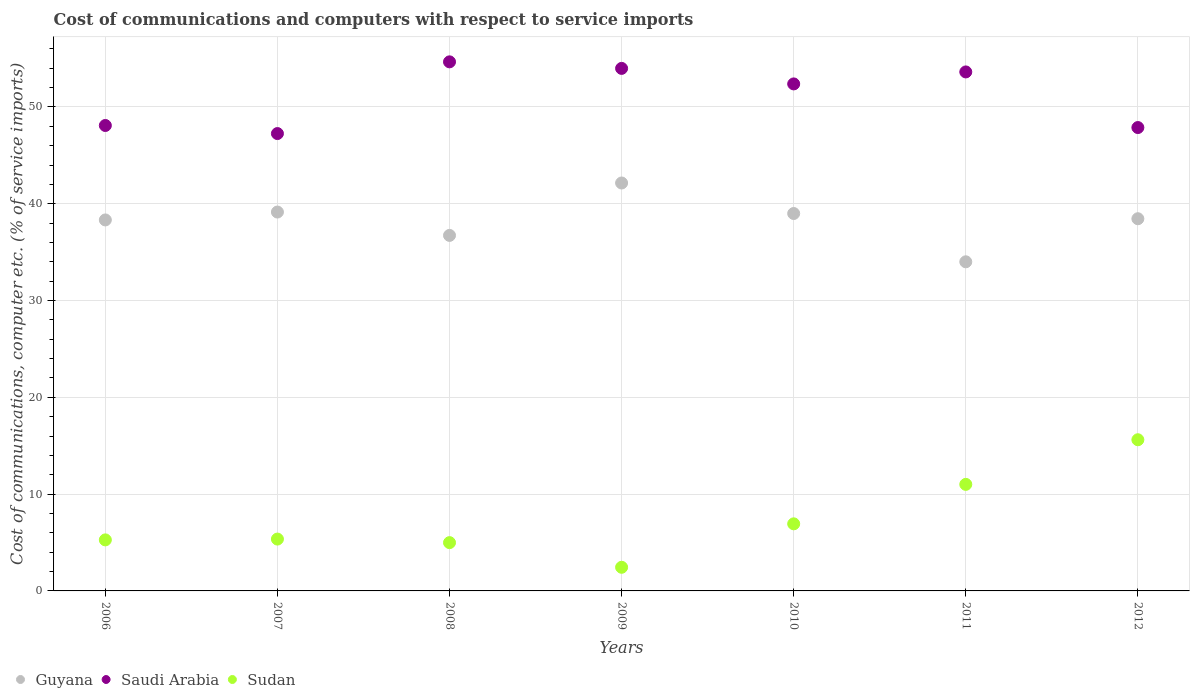Is the number of dotlines equal to the number of legend labels?
Your answer should be very brief. Yes. What is the cost of communications and computers in Guyana in 2006?
Keep it short and to the point. 38.33. Across all years, what is the maximum cost of communications and computers in Saudi Arabia?
Ensure brevity in your answer.  54.66. Across all years, what is the minimum cost of communications and computers in Saudi Arabia?
Offer a terse response. 47.25. In which year was the cost of communications and computers in Guyana minimum?
Ensure brevity in your answer.  2011. What is the total cost of communications and computers in Sudan in the graph?
Your response must be concise. 51.61. What is the difference between the cost of communications and computers in Saudi Arabia in 2008 and that in 2011?
Keep it short and to the point. 1.04. What is the difference between the cost of communications and computers in Guyana in 2009 and the cost of communications and computers in Saudi Arabia in 2008?
Your answer should be very brief. -12.52. What is the average cost of communications and computers in Guyana per year?
Offer a very short reply. 38.25. In the year 2006, what is the difference between the cost of communications and computers in Guyana and cost of communications and computers in Saudi Arabia?
Keep it short and to the point. -9.76. What is the ratio of the cost of communications and computers in Saudi Arabia in 2006 to that in 2011?
Give a very brief answer. 0.9. Is the cost of communications and computers in Guyana in 2011 less than that in 2012?
Keep it short and to the point. Yes. What is the difference between the highest and the second highest cost of communications and computers in Sudan?
Provide a short and direct response. 4.61. What is the difference between the highest and the lowest cost of communications and computers in Saudi Arabia?
Provide a short and direct response. 7.41. Is the sum of the cost of communications and computers in Sudan in 2006 and 2009 greater than the maximum cost of communications and computers in Saudi Arabia across all years?
Your answer should be compact. No. Does the cost of communications and computers in Guyana monotonically increase over the years?
Ensure brevity in your answer.  No. Is the cost of communications and computers in Sudan strictly greater than the cost of communications and computers in Saudi Arabia over the years?
Keep it short and to the point. No. How many dotlines are there?
Offer a very short reply. 3. How many years are there in the graph?
Your response must be concise. 7. What is the difference between two consecutive major ticks on the Y-axis?
Keep it short and to the point. 10. Are the values on the major ticks of Y-axis written in scientific E-notation?
Ensure brevity in your answer.  No. Does the graph contain grids?
Make the answer very short. Yes. Where does the legend appear in the graph?
Give a very brief answer. Bottom left. What is the title of the graph?
Your answer should be compact. Cost of communications and computers with respect to service imports. Does "Sao Tome and Principe" appear as one of the legend labels in the graph?
Your answer should be very brief. No. What is the label or title of the Y-axis?
Offer a very short reply. Cost of communications, computer etc. (% of service imports). What is the Cost of communications, computer etc. (% of service imports) in Guyana in 2006?
Offer a terse response. 38.33. What is the Cost of communications, computer etc. (% of service imports) of Saudi Arabia in 2006?
Ensure brevity in your answer.  48.08. What is the Cost of communications, computer etc. (% of service imports) of Sudan in 2006?
Your response must be concise. 5.27. What is the Cost of communications, computer etc. (% of service imports) of Guyana in 2007?
Your response must be concise. 39.14. What is the Cost of communications, computer etc. (% of service imports) of Saudi Arabia in 2007?
Your answer should be very brief. 47.25. What is the Cost of communications, computer etc. (% of service imports) of Sudan in 2007?
Make the answer very short. 5.36. What is the Cost of communications, computer etc. (% of service imports) of Guyana in 2008?
Your answer should be very brief. 36.73. What is the Cost of communications, computer etc. (% of service imports) in Saudi Arabia in 2008?
Ensure brevity in your answer.  54.66. What is the Cost of communications, computer etc. (% of service imports) of Sudan in 2008?
Provide a short and direct response. 4.99. What is the Cost of communications, computer etc. (% of service imports) of Guyana in 2009?
Ensure brevity in your answer.  42.14. What is the Cost of communications, computer etc. (% of service imports) of Saudi Arabia in 2009?
Your answer should be very brief. 53.98. What is the Cost of communications, computer etc. (% of service imports) of Sudan in 2009?
Offer a terse response. 2.44. What is the Cost of communications, computer etc. (% of service imports) in Guyana in 2010?
Your answer should be compact. 38.99. What is the Cost of communications, computer etc. (% of service imports) of Saudi Arabia in 2010?
Your answer should be compact. 52.38. What is the Cost of communications, computer etc. (% of service imports) of Sudan in 2010?
Keep it short and to the point. 6.93. What is the Cost of communications, computer etc. (% of service imports) in Guyana in 2011?
Provide a short and direct response. 34. What is the Cost of communications, computer etc. (% of service imports) in Saudi Arabia in 2011?
Your response must be concise. 53.62. What is the Cost of communications, computer etc. (% of service imports) in Sudan in 2011?
Keep it short and to the point. 11.01. What is the Cost of communications, computer etc. (% of service imports) of Guyana in 2012?
Your answer should be very brief. 38.45. What is the Cost of communications, computer etc. (% of service imports) in Saudi Arabia in 2012?
Give a very brief answer. 47.87. What is the Cost of communications, computer etc. (% of service imports) of Sudan in 2012?
Give a very brief answer. 15.62. Across all years, what is the maximum Cost of communications, computer etc. (% of service imports) of Guyana?
Make the answer very short. 42.14. Across all years, what is the maximum Cost of communications, computer etc. (% of service imports) in Saudi Arabia?
Offer a terse response. 54.66. Across all years, what is the maximum Cost of communications, computer etc. (% of service imports) of Sudan?
Keep it short and to the point. 15.62. Across all years, what is the minimum Cost of communications, computer etc. (% of service imports) in Guyana?
Offer a very short reply. 34. Across all years, what is the minimum Cost of communications, computer etc. (% of service imports) of Saudi Arabia?
Keep it short and to the point. 47.25. Across all years, what is the minimum Cost of communications, computer etc. (% of service imports) of Sudan?
Your response must be concise. 2.44. What is the total Cost of communications, computer etc. (% of service imports) in Guyana in the graph?
Ensure brevity in your answer.  267.77. What is the total Cost of communications, computer etc. (% of service imports) of Saudi Arabia in the graph?
Make the answer very short. 357.83. What is the total Cost of communications, computer etc. (% of service imports) of Sudan in the graph?
Make the answer very short. 51.61. What is the difference between the Cost of communications, computer etc. (% of service imports) of Guyana in 2006 and that in 2007?
Provide a short and direct response. -0.82. What is the difference between the Cost of communications, computer etc. (% of service imports) of Saudi Arabia in 2006 and that in 2007?
Keep it short and to the point. 0.83. What is the difference between the Cost of communications, computer etc. (% of service imports) of Sudan in 2006 and that in 2007?
Provide a succinct answer. -0.08. What is the difference between the Cost of communications, computer etc. (% of service imports) of Guyana in 2006 and that in 2008?
Ensure brevity in your answer.  1.6. What is the difference between the Cost of communications, computer etc. (% of service imports) of Saudi Arabia in 2006 and that in 2008?
Your answer should be compact. -6.57. What is the difference between the Cost of communications, computer etc. (% of service imports) of Sudan in 2006 and that in 2008?
Provide a succinct answer. 0.28. What is the difference between the Cost of communications, computer etc. (% of service imports) of Guyana in 2006 and that in 2009?
Keep it short and to the point. -3.82. What is the difference between the Cost of communications, computer etc. (% of service imports) in Saudi Arabia in 2006 and that in 2009?
Keep it short and to the point. -5.9. What is the difference between the Cost of communications, computer etc. (% of service imports) in Sudan in 2006 and that in 2009?
Keep it short and to the point. 2.83. What is the difference between the Cost of communications, computer etc. (% of service imports) of Guyana in 2006 and that in 2010?
Offer a very short reply. -0.66. What is the difference between the Cost of communications, computer etc. (% of service imports) in Saudi Arabia in 2006 and that in 2010?
Offer a terse response. -4.3. What is the difference between the Cost of communications, computer etc. (% of service imports) in Sudan in 2006 and that in 2010?
Make the answer very short. -1.66. What is the difference between the Cost of communications, computer etc. (% of service imports) of Guyana in 2006 and that in 2011?
Offer a terse response. 4.33. What is the difference between the Cost of communications, computer etc. (% of service imports) in Saudi Arabia in 2006 and that in 2011?
Provide a succinct answer. -5.53. What is the difference between the Cost of communications, computer etc. (% of service imports) of Sudan in 2006 and that in 2011?
Your answer should be very brief. -5.73. What is the difference between the Cost of communications, computer etc. (% of service imports) in Guyana in 2006 and that in 2012?
Ensure brevity in your answer.  -0.13. What is the difference between the Cost of communications, computer etc. (% of service imports) of Saudi Arabia in 2006 and that in 2012?
Provide a short and direct response. 0.21. What is the difference between the Cost of communications, computer etc. (% of service imports) of Sudan in 2006 and that in 2012?
Your answer should be very brief. -10.35. What is the difference between the Cost of communications, computer etc. (% of service imports) in Guyana in 2007 and that in 2008?
Offer a terse response. 2.41. What is the difference between the Cost of communications, computer etc. (% of service imports) in Saudi Arabia in 2007 and that in 2008?
Provide a succinct answer. -7.41. What is the difference between the Cost of communications, computer etc. (% of service imports) in Sudan in 2007 and that in 2008?
Offer a very short reply. 0.37. What is the difference between the Cost of communications, computer etc. (% of service imports) in Guyana in 2007 and that in 2009?
Your answer should be very brief. -3. What is the difference between the Cost of communications, computer etc. (% of service imports) in Saudi Arabia in 2007 and that in 2009?
Your answer should be compact. -6.73. What is the difference between the Cost of communications, computer etc. (% of service imports) of Sudan in 2007 and that in 2009?
Ensure brevity in your answer.  2.91. What is the difference between the Cost of communications, computer etc. (% of service imports) in Guyana in 2007 and that in 2010?
Offer a terse response. 0.15. What is the difference between the Cost of communications, computer etc. (% of service imports) in Saudi Arabia in 2007 and that in 2010?
Offer a terse response. -5.13. What is the difference between the Cost of communications, computer etc. (% of service imports) in Sudan in 2007 and that in 2010?
Provide a succinct answer. -1.57. What is the difference between the Cost of communications, computer etc. (% of service imports) in Guyana in 2007 and that in 2011?
Ensure brevity in your answer.  5.14. What is the difference between the Cost of communications, computer etc. (% of service imports) of Saudi Arabia in 2007 and that in 2011?
Your answer should be very brief. -6.37. What is the difference between the Cost of communications, computer etc. (% of service imports) of Sudan in 2007 and that in 2011?
Make the answer very short. -5.65. What is the difference between the Cost of communications, computer etc. (% of service imports) in Guyana in 2007 and that in 2012?
Your answer should be very brief. 0.69. What is the difference between the Cost of communications, computer etc. (% of service imports) of Saudi Arabia in 2007 and that in 2012?
Your answer should be very brief. -0.62. What is the difference between the Cost of communications, computer etc. (% of service imports) of Sudan in 2007 and that in 2012?
Provide a short and direct response. -10.26. What is the difference between the Cost of communications, computer etc. (% of service imports) in Guyana in 2008 and that in 2009?
Give a very brief answer. -5.42. What is the difference between the Cost of communications, computer etc. (% of service imports) of Saudi Arabia in 2008 and that in 2009?
Provide a succinct answer. 0.68. What is the difference between the Cost of communications, computer etc. (% of service imports) in Sudan in 2008 and that in 2009?
Your answer should be compact. 2.55. What is the difference between the Cost of communications, computer etc. (% of service imports) of Guyana in 2008 and that in 2010?
Your response must be concise. -2.26. What is the difference between the Cost of communications, computer etc. (% of service imports) in Saudi Arabia in 2008 and that in 2010?
Your response must be concise. 2.28. What is the difference between the Cost of communications, computer etc. (% of service imports) in Sudan in 2008 and that in 2010?
Offer a very short reply. -1.94. What is the difference between the Cost of communications, computer etc. (% of service imports) of Guyana in 2008 and that in 2011?
Provide a short and direct response. 2.73. What is the difference between the Cost of communications, computer etc. (% of service imports) in Saudi Arabia in 2008 and that in 2011?
Provide a succinct answer. 1.04. What is the difference between the Cost of communications, computer etc. (% of service imports) of Sudan in 2008 and that in 2011?
Offer a terse response. -6.02. What is the difference between the Cost of communications, computer etc. (% of service imports) of Guyana in 2008 and that in 2012?
Offer a very short reply. -1.72. What is the difference between the Cost of communications, computer etc. (% of service imports) in Saudi Arabia in 2008 and that in 2012?
Keep it short and to the point. 6.79. What is the difference between the Cost of communications, computer etc. (% of service imports) in Sudan in 2008 and that in 2012?
Give a very brief answer. -10.63. What is the difference between the Cost of communications, computer etc. (% of service imports) in Guyana in 2009 and that in 2010?
Make the answer very short. 3.15. What is the difference between the Cost of communications, computer etc. (% of service imports) of Saudi Arabia in 2009 and that in 2010?
Offer a very short reply. 1.6. What is the difference between the Cost of communications, computer etc. (% of service imports) of Sudan in 2009 and that in 2010?
Your answer should be very brief. -4.49. What is the difference between the Cost of communications, computer etc. (% of service imports) in Guyana in 2009 and that in 2011?
Offer a very short reply. 8.14. What is the difference between the Cost of communications, computer etc. (% of service imports) of Saudi Arabia in 2009 and that in 2011?
Offer a terse response. 0.37. What is the difference between the Cost of communications, computer etc. (% of service imports) of Sudan in 2009 and that in 2011?
Offer a terse response. -8.56. What is the difference between the Cost of communications, computer etc. (% of service imports) in Guyana in 2009 and that in 2012?
Give a very brief answer. 3.69. What is the difference between the Cost of communications, computer etc. (% of service imports) in Saudi Arabia in 2009 and that in 2012?
Your answer should be compact. 6.11. What is the difference between the Cost of communications, computer etc. (% of service imports) in Sudan in 2009 and that in 2012?
Your response must be concise. -13.18. What is the difference between the Cost of communications, computer etc. (% of service imports) in Guyana in 2010 and that in 2011?
Give a very brief answer. 4.99. What is the difference between the Cost of communications, computer etc. (% of service imports) in Saudi Arabia in 2010 and that in 2011?
Ensure brevity in your answer.  -1.24. What is the difference between the Cost of communications, computer etc. (% of service imports) of Sudan in 2010 and that in 2011?
Your answer should be compact. -4.08. What is the difference between the Cost of communications, computer etc. (% of service imports) of Guyana in 2010 and that in 2012?
Offer a terse response. 0.54. What is the difference between the Cost of communications, computer etc. (% of service imports) of Saudi Arabia in 2010 and that in 2012?
Your response must be concise. 4.51. What is the difference between the Cost of communications, computer etc. (% of service imports) in Sudan in 2010 and that in 2012?
Your response must be concise. -8.69. What is the difference between the Cost of communications, computer etc. (% of service imports) of Guyana in 2011 and that in 2012?
Provide a succinct answer. -4.45. What is the difference between the Cost of communications, computer etc. (% of service imports) in Saudi Arabia in 2011 and that in 2012?
Ensure brevity in your answer.  5.75. What is the difference between the Cost of communications, computer etc. (% of service imports) of Sudan in 2011 and that in 2012?
Keep it short and to the point. -4.61. What is the difference between the Cost of communications, computer etc. (% of service imports) of Guyana in 2006 and the Cost of communications, computer etc. (% of service imports) of Saudi Arabia in 2007?
Give a very brief answer. -8.92. What is the difference between the Cost of communications, computer etc. (% of service imports) of Guyana in 2006 and the Cost of communications, computer etc. (% of service imports) of Sudan in 2007?
Provide a short and direct response. 32.97. What is the difference between the Cost of communications, computer etc. (% of service imports) of Saudi Arabia in 2006 and the Cost of communications, computer etc. (% of service imports) of Sudan in 2007?
Provide a short and direct response. 42.73. What is the difference between the Cost of communications, computer etc. (% of service imports) of Guyana in 2006 and the Cost of communications, computer etc. (% of service imports) of Saudi Arabia in 2008?
Your response must be concise. -16.33. What is the difference between the Cost of communications, computer etc. (% of service imports) of Guyana in 2006 and the Cost of communications, computer etc. (% of service imports) of Sudan in 2008?
Your answer should be very brief. 33.34. What is the difference between the Cost of communications, computer etc. (% of service imports) in Saudi Arabia in 2006 and the Cost of communications, computer etc. (% of service imports) in Sudan in 2008?
Ensure brevity in your answer.  43.09. What is the difference between the Cost of communications, computer etc. (% of service imports) of Guyana in 2006 and the Cost of communications, computer etc. (% of service imports) of Saudi Arabia in 2009?
Offer a terse response. -15.66. What is the difference between the Cost of communications, computer etc. (% of service imports) in Guyana in 2006 and the Cost of communications, computer etc. (% of service imports) in Sudan in 2009?
Provide a succinct answer. 35.88. What is the difference between the Cost of communications, computer etc. (% of service imports) in Saudi Arabia in 2006 and the Cost of communications, computer etc. (% of service imports) in Sudan in 2009?
Provide a short and direct response. 45.64. What is the difference between the Cost of communications, computer etc. (% of service imports) of Guyana in 2006 and the Cost of communications, computer etc. (% of service imports) of Saudi Arabia in 2010?
Offer a very short reply. -14.05. What is the difference between the Cost of communications, computer etc. (% of service imports) of Guyana in 2006 and the Cost of communications, computer etc. (% of service imports) of Sudan in 2010?
Your answer should be very brief. 31.39. What is the difference between the Cost of communications, computer etc. (% of service imports) of Saudi Arabia in 2006 and the Cost of communications, computer etc. (% of service imports) of Sudan in 2010?
Give a very brief answer. 41.15. What is the difference between the Cost of communications, computer etc. (% of service imports) of Guyana in 2006 and the Cost of communications, computer etc. (% of service imports) of Saudi Arabia in 2011?
Make the answer very short. -15.29. What is the difference between the Cost of communications, computer etc. (% of service imports) of Guyana in 2006 and the Cost of communications, computer etc. (% of service imports) of Sudan in 2011?
Give a very brief answer. 27.32. What is the difference between the Cost of communications, computer etc. (% of service imports) in Saudi Arabia in 2006 and the Cost of communications, computer etc. (% of service imports) in Sudan in 2011?
Provide a succinct answer. 37.08. What is the difference between the Cost of communications, computer etc. (% of service imports) of Guyana in 2006 and the Cost of communications, computer etc. (% of service imports) of Saudi Arabia in 2012?
Offer a very short reply. -9.54. What is the difference between the Cost of communications, computer etc. (% of service imports) of Guyana in 2006 and the Cost of communications, computer etc. (% of service imports) of Sudan in 2012?
Provide a succinct answer. 22.71. What is the difference between the Cost of communications, computer etc. (% of service imports) in Saudi Arabia in 2006 and the Cost of communications, computer etc. (% of service imports) in Sudan in 2012?
Offer a terse response. 32.46. What is the difference between the Cost of communications, computer etc. (% of service imports) in Guyana in 2007 and the Cost of communications, computer etc. (% of service imports) in Saudi Arabia in 2008?
Your response must be concise. -15.52. What is the difference between the Cost of communications, computer etc. (% of service imports) in Guyana in 2007 and the Cost of communications, computer etc. (% of service imports) in Sudan in 2008?
Keep it short and to the point. 34.15. What is the difference between the Cost of communications, computer etc. (% of service imports) in Saudi Arabia in 2007 and the Cost of communications, computer etc. (% of service imports) in Sudan in 2008?
Offer a terse response. 42.26. What is the difference between the Cost of communications, computer etc. (% of service imports) in Guyana in 2007 and the Cost of communications, computer etc. (% of service imports) in Saudi Arabia in 2009?
Provide a short and direct response. -14.84. What is the difference between the Cost of communications, computer etc. (% of service imports) in Guyana in 2007 and the Cost of communications, computer etc. (% of service imports) in Sudan in 2009?
Provide a short and direct response. 36.7. What is the difference between the Cost of communications, computer etc. (% of service imports) in Saudi Arabia in 2007 and the Cost of communications, computer etc. (% of service imports) in Sudan in 2009?
Keep it short and to the point. 44.81. What is the difference between the Cost of communications, computer etc. (% of service imports) of Guyana in 2007 and the Cost of communications, computer etc. (% of service imports) of Saudi Arabia in 2010?
Keep it short and to the point. -13.24. What is the difference between the Cost of communications, computer etc. (% of service imports) of Guyana in 2007 and the Cost of communications, computer etc. (% of service imports) of Sudan in 2010?
Give a very brief answer. 32.21. What is the difference between the Cost of communications, computer etc. (% of service imports) of Saudi Arabia in 2007 and the Cost of communications, computer etc. (% of service imports) of Sudan in 2010?
Give a very brief answer. 40.32. What is the difference between the Cost of communications, computer etc. (% of service imports) of Guyana in 2007 and the Cost of communications, computer etc. (% of service imports) of Saudi Arabia in 2011?
Offer a very short reply. -14.47. What is the difference between the Cost of communications, computer etc. (% of service imports) in Guyana in 2007 and the Cost of communications, computer etc. (% of service imports) in Sudan in 2011?
Keep it short and to the point. 28.13. What is the difference between the Cost of communications, computer etc. (% of service imports) of Saudi Arabia in 2007 and the Cost of communications, computer etc. (% of service imports) of Sudan in 2011?
Offer a terse response. 36.24. What is the difference between the Cost of communications, computer etc. (% of service imports) in Guyana in 2007 and the Cost of communications, computer etc. (% of service imports) in Saudi Arabia in 2012?
Provide a short and direct response. -8.73. What is the difference between the Cost of communications, computer etc. (% of service imports) of Guyana in 2007 and the Cost of communications, computer etc. (% of service imports) of Sudan in 2012?
Offer a terse response. 23.52. What is the difference between the Cost of communications, computer etc. (% of service imports) in Saudi Arabia in 2007 and the Cost of communications, computer etc. (% of service imports) in Sudan in 2012?
Make the answer very short. 31.63. What is the difference between the Cost of communications, computer etc. (% of service imports) of Guyana in 2008 and the Cost of communications, computer etc. (% of service imports) of Saudi Arabia in 2009?
Ensure brevity in your answer.  -17.25. What is the difference between the Cost of communications, computer etc. (% of service imports) in Guyana in 2008 and the Cost of communications, computer etc. (% of service imports) in Sudan in 2009?
Your answer should be compact. 34.28. What is the difference between the Cost of communications, computer etc. (% of service imports) in Saudi Arabia in 2008 and the Cost of communications, computer etc. (% of service imports) in Sudan in 2009?
Ensure brevity in your answer.  52.21. What is the difference between the Cost of communications, computer etc. (% of service imports) of Guyana in 2008 and the Cost of communications, computer etc. (% of service imports) of Saudi Arabia in 2010?
Your answer should be compact. -15.65. What is the difference between the Cost of communications, computer etc. (% of service imports) of Guyana in 2008 and the Cost of communications, computer etc. (% of service imports) of Sudan in 2010?
Offer a terse response. 29.8. What is the difference between the Cost of communications, computer etc. (% of service imports) of Saudi Arabia in 2008 and the Cost of communications, computer etc. (% of service imports) of Sudan in 2010?
Offer a very short reply. 47.73. What is the difference between the Cost of communications, computer etc. (% of service imports) in Guyana in 2008 and the Cost of communications, computer etc. (% of service imports) in Saudi Arabia in 2011?
Your answer should be compact. -16.89. What is the difference between the Cost of communications, computer etc. (% of service imports) in Guyana in 2008 and the Cost of communications, computer etc. (% of service imports) in Sudan in 2011?
Provide a short and direct response. 25.72. What is the difference between the Cost of communications, computer etc. (% of service imports) of Saudi Arabia in 2008 and the Cost of communications, computer etc. (% of service imports) of Sudan in 2011?
Give a very brief answer. 43.65. What is the difference between the Cost of communications, computer etc. (% of service imports) of Guyana in 2008 and the Cost of communications, computer etc. (% of service imports) of Saudi Arabia in 2012?
Provide a short and direct response. -11.14. What is the difference between the Cost of communications, computer etc. (% of service imports) in Guyana in 2008 and the Cost of communications, computer etc. (% of service imports) in Sudan in 2012?
Keep it short and to the point. 21.11. What is the difference between the Cost of communications, computer etc. (% of service imports) in Saudi Arabia in 2008 and the Cost of communications, computer etc. (% of service imports) in Sudan in 2012?
Offer a very short reply. 39.04. What is the difference between the Cost of communications, computer etc. (% of service imports) in Guyana in 2009 and the Cost of communications, computer etc. (% of service imports) in Saudi Arabia in 2010?
Your response must be concise. -10.24. What is the difference between the Cost of communications, computer etc. (% of service imports) of Guyana in 2009 and the Cost of communications, computer etc. (% of service imports) of Sudan in 2010?
Provide a succinct answer. 35.21. What is the difference between the Cost of communications, computer etc. (% of service imports) of Saudi Arabia in 2009 and the Cost of communications, computer etc. (% of service imports) of Sudan in 2010?
Offer a very short reply. 47.05. What is the difference between the Cost of communications, computer etc. (% of service imports) in Guyana in 2009 and the Cost of communications, computer etc. (% of service imports) in Saudi Arabia in 2011?
Keep it short and to the point. -11.47. What is the difference between the Cost of communications, computer etc. (% of service imports) in Guyana in 2009 and the Cost of communications, computer etc. (% of service imports) in Sudan in 2011?
Your response must be concise. 31.13. What is the difference between the Cost of communications, computer etc. (% of service imports) of Saudi Arabia in 2009 and the Cost of communications, computer etc. (% of service imports) of Sudan in 2011?
Give a very brief answer. 42.97. What is the difference between the Cost of communications, computer etc. (% of service imports) in Guyana in 2009 and the Cost of communications, computer etc. (% of service imports) in Saudi Arabia in 2012?
Give a very brief answer. -5.73. What is the difference between the Cost of communications, computer etc. (% of service imports) in Guyana in 2009 and the Cost of communications, computer etc. (% of service imports) in Sudan in 2012?
Ensure brevity in your answer.  26.52. What is the difference between the Cost of communications, computer etc. (% of service imports) in Saudi Arabia in 2009 and the Cost of communications, computer etc. (% of service imports) in Sudan in 2012?
Ensure brevity in your answer.  38.36. What is the difference between the Cost of communications, computer etc. (% of service imports) in Guyana in 2010 and the Cost of communications, computer etc. (% of service imports) in Saudi Arabia in 2011?
Provide a succinct answer. -14.63. What is the difference between the Cost of communications, computer etc. (% of service imports) in Guyana in 2010 and the Cost of communications, computer etc. (% of service imports) in Sudan in 2011?
Provide a succinct answer. 27.98. What is the difference between the Cost of communications, computer etc. (% of service imports) of Saudi Arabia in 2010 and the Cost of communications, computer etc. (% of service imports) of Sudan in 2011?
Keep it short and to the point. 41.37. What is the difference between the Cost of communications, computer etc. (% of service imports) in Guyana in 2010 and the Cost of communications, computer etc. (% of service imports) in Saudi Arabia in 2012?
Offer a terse response. -8.88. What is the difference between the Cost of communications, computer etc. (% of service imports) in Guyana in 2010 and the Cost of communications, computer etc. (% of service imports) in Sudan in 2012?
Your answer should be compact. 23.37. What is the difference between the Cost of communications, computer etc. (% of service imports) of Saudi Arabia in 2010 and the Cost of communications, computer etc. (% of service imports) of Sudan in 2012?
Make the answer very short. 36.76. What is the difference between the Cost of communications, computer etc. (% of service imports) in Guyana in 2011 and the Cost of communications, computer etc. (% of service imports) in Saudi Arabia in 2012?
Your answer should be very brief. -13.87. What is the difference between the Cost of communications, computer etc. (% of service imports) of Guyana in 2011 and the Cost of communications, computer etc. (% of service imports) of Sudan in 2012?
Offer a terse response. 18.38. What is the difference between the Cost of communications, computer etc. (% of service imports) in Saudi Arabia in 2011 and the Cost of communications, computer etc. (% of service imports) in Sudan in 2012?
Keep it short and to the point. 38. What is the average Cost of communications, computer etc. (% of service imports) of Guyana per year?
Provide a short and direct response. 38.25. What is the average Cost of communications, computer etc. (% of service imports) of Saudi Arabia per year?
Offer a terse response. 51.12. What is the average Cost of communications, computer etc. (% of service imports) in Sudan per year?
Your answer should be compact. 7.37. In the year 2006, what is the difference between the Cost of communications, computer etc. (% of service imports) of Guyana and Cost of communications, computer etc. (% of service imports) of Saudi Arabia?
Ensure brevity in your answer.  -9.76. In the year 2006, what is the difference between the Cost of communications, computer etc. (% of service imports) of Guyana and Cost of communications, computer etc. (% of service imports) of Sudan?
Your answer should be very brief. 33.05. In the year 2006, what is the difference between the Cost of communications, computer etc. (% of service imports) of Saudi Arabia and Cost of communications, computer etc. (% of service imports) of Sudan?
Your response must be concise. 42.81. In the year 2007, what is the difference between the Cost of communications, computer etc. (% of service imports) of Guyana and Cost of communications, computer etc. (% of service imports) of Saudi Arabia?
Offer a terse response. -8.11. In the year 2007, what is the difference between the Cost of communications, computer etc. (% of service imports) of Guyana and Cost of communications, computer etc. (% of service imports) of Sudan?
Your answer should be very brief. 33.78. In the year 2007, what is the difference between the Cost of communications, computer etc. (% of service imports) of Saudi Arabia and Cost of communications, computer etc. (% of service imports) of Sudan?
Offer a very short reply. 41.89. In the year 2008, what is the difference between the Cost of communications, computer etc. (% of service imports) of Guyana and Cost of communications, computer etc. (% of service imports) of Saudi Arabia?
Keep it short and to the point. -17.93. In the year 2008, what is the difference between the Cost of communications, computer etc. (% of service imports) in Guyana and Cost of communications, computer etc. (% of service imports) in Sudan?
Your answer should be very brief. 31.74. In the year 2008, what is the difference between the Cost of communications, computer etc. (% of service imports) of Saudi Arabia and Cost of communications, computer etc. (% of service imports) of Sudan?
Your response must be concise. 49.67. In the year 2009, what is the difference between the Cost of communications, computer etc. (% of service imports) of Guyana and Cost of communications, computer etc. (% of service imports) of Saudi Arabia?
Your response must be concise. -11.84. In the year 2009, what is the difference between the Cost of communications, computer etc. (% of service imports) in Guyana and Cost of communications, computer etc. (% of service imports) in Sudan?
Keep it short and to the point. 39.7. In the year 2009, what is the difference between the Cost of communications, computer etc. (% of service imports) of Saudi Arabia and Cost of communications, computer etc. (% of service imports) of Sudan?
Your answer should be compact. 51.54. In the year 2010, what is the difference between the Cost of communications, computer etc. (% of service imports) of Guyana and Cost of communications, computer etc. (% of service imports) of Saudi Arabia?
Ensure brevity in your answer.  -13.39. In the year 2010, what is the difference between the Cost of communications, computer etc. (% of service imports) in Guyana and Cost of communications, computer etc. (% of service imports) in Sudan?
Make the answer very short. 32.06. In the year 2010, what is the difference between the Cost of communications, computer etc. (% of service imports) in Saudi Arabia and Cost of communications, computer etc. (% of service imports) in Sudan?
Give a very brief answer. 45.45. In the year 2011, what is the difference between the Cost of communications, computer etc. (% of service imports) of Guyana and Cost of communications, computer etc. (% of service imports) of Saudi Arabia?
Your answer should be compact. -19.62. In the year 2011, what is the difference between the Cost of communications, computer etc. (% of service imports) of Guyana and Cost of communications, computer etc. (% of service imports) of Sudan?
Your answer should be very brief. 22.99. In the year 2011, what is the difference between the Cost of communications, computer etc. (% of service imports) in Saudi Arabia and Cost of communications, computer etc. (% of service imports) in Sudan?
Offer a very short reply. 42.61. In the year 2012, what is the difference between the Cost of communications, computer etc. (% of service imports) in Guyana and Cost of communications, computer etc. (% of service imports) in Saudi Arabia?
Offer a very short reply. -9.42. In the year 2012, what is the difference between the Cost of communications, computer etc. (% of service imports) of Guyana and Cost of communications, computer etc. (% of service imports) of Sudan?
Your answer should be compact. 22.83. In the year 2012, what is the difference between the Cost of communications, computer etc. (% of service imports) of Saudi Arabia and Cost of communications, computer etc. (% of service imports) of Sudan?
Give a very brief answer. 32.25. What is the ratio of the Cost of communications, computer etc. (% of service imports) of Guyana in 2006 to that in 2007?
Provide a succinct answer. 0.98. What is the ratio of the Cost of communications, computer etc. (% of service imports) of Saudi Arabia in 2006 to that in 2007?
Ensure brevity in your answer.  1.02. What is the ratio of the Cost of communications, computer etc. (% of service imports) in Sudan in 2006 to that in 2007?
Offer a very short reply. 0.98. What is the ratio of the Cost of communications, computer etc. (% of service imports) in Guyana in 2006 to that in 2008?
Your answer should be very brief. 1.04. What is the ratio of the Cost of communications, computer etc. (% of service imports) of Saudi Arabia in 2006 to that in 2008?
Provide a succinct answer. 0.88. What is the ratio of the Cost of communications, computer etc. (% of service imports) in Sudan in 2006 to that in 2008?
Offer a terse response. 1.06. What is the ratio of the Cost of communications, computer etc. (% of service imports) of Guyana in 2006 to that in 2009?
Your answer should be compact. 0.91. What is the ratio of the Cost of communications, computer etc. (% of service imports) of Saudi Arabia in 2006 to that in 2009?
Provide a short and direct response. 0.89. What is the ratio of the Cost of communications, computer etc. (% of service imports) in Sudan in 2006 to that in 2009?
Your answer should be compact. 2.16. What is the ratio of the Cost of communications, computer etc. (% of service imports) of Saudi Arabia in 2006 to that in 2010?
Offer a terse response. 0.92. What is the ratio of the Cost of communications, computer etc. (% of service imports) in Sudan in 2006 to that in 2010?
Make the answer very short. 0.76. What is the ratio of the Cost of communications, computer etc. (% of service imports) in Guyana in 2006 to that in 2011?
Provide a short and direct response. 1.13. What is the ratio of the Cost of communications, computer etc. (% of service imports) of Saudi Arabia in 2006 to that in 2011?
Your response must be concise. 0.9. What is the ratio of the Cost of communications, computer etc. (% of service imports) of Sudan in 2006 to that in 2011?
Give a very brief answer. 0.48. What is the ratio of the Cost of communications, computer etc. (% of service imports) in Guyana in 2006 to that in 2012?
Your response must be concise. 1. What is the ratio of the Cost of communications, computer etc. (% of service imports) in Saudi Arabia in 2006 to that in 2012?
Ensure brevity in your answer.  1. What is the ratio of the Cost of communications, computer etc. (% of service imports) in Sudan in 2006 to that in 2012?
Your response must be concise. 0.34. What is the ratio of the Cost of communications, computer etc. (% of service imports) of Guyana in 2007 to that in 2008?
Your answer should be compact. 1.07. What is the ratio of the Cost of communications, computer etc. (% of service imports) in Saudi Arabia in 2007 to that in 2008?
Offer a very short reply. 0.86. What is the ratio of the Cost of communications, computer etc. (% of service imports) in Sudan in 2007 to that in 2008?
Your response must be concise. 1.07. What is the ratio of the Cost of communications, computer etc. (% of service imports) of Guyana in 2007 to that in 2009?
Offer a very short reply. 0.93. What is the ratio of the Cost of communications, computer etc. (% of service imports) of Saudi Arabia in 2007 to that in 2009?
Ensure brevity in your answer.  0.88. What is the ratio of the Cost of communications, computer etc. (% of service imports) in Sudan in 2007 to that in 2009?
Give a very brief answer. 2.19. What is the ratio of the Cost of communications, computer etc. (% of service imports) in Guyana in 2007 to that in 2010?
Offer a terse response. 1. What is the ratio of the Cost of communications, computer etc. (% of service imports) in Saudi Arabia in 2007 to that in 2010?
Your response must be concise. 0.9. What is the ratio of the Cost of communications, computer etc. (% of service imports) of Sudan in 2007 to that in 2010?
Provide a succinct answer. 0.77. What is the ratio of the Cost of communications, computer etc. (% of service imports) of Guyana in 2007 to that in 2011?
Your response must be concise. 1.15. What is the ratio of the Cost of communications, computer etc. (% of service imports) in Saudi Arabia in 2007 to that in 2011?
Provide a succinct answer. 0.88. What is the ratio of the Cost of communications, computer etc. (% of service imports) of Sudan in 2007 to that in 2011?
Give a very brief answer. 0.49. What is the ratio of the Cost of communications, computer etc. (% of service imports) of Sudan in 2007 to that in 2012?
Ensure brevity in your answer.  0.34. What is the ratio of the Cost of communications, computer etc. (% of service imports) of Guyana in 2008 to that in 2009?
Provide a succinct answer. 0.87. What is the ratio of the Cost of communications, computer etc. (% of service imports) in Saudi Arabia in 2008 to that in 2009?
Provide a short and direct response. 1.01. What is the ratio of the Cost of communications, computer etc. (% of service imports) in Sudan in 2008 to that in 2009?
Provide a succinct answer. 2.04. What is the ratio of the Cost of communications, computer etc. (% of service imports) of Guyana in 2008 to that in 2010?
Give a very brief answer. 0.94. What is the ratio of the Cost of communications, computer etc. (% of service imports) of Saudi Arabia in 2008 to that in 2010?
Provide a short and direct response. 1.04. What is the ratio of the Cost of communications, computer etc. (% of service imports) in Sudan in 2008 to that in 2010?
Your response must be concise. 0.72. What is the ratio of the Cost of communications, computer etc. (% of service imports) of Guyana in 2008 to that in 2011?
Give a very brief answer. 1.08. What is the ratio of the Cost of communications, computer etc. (% of service imports) of Saudi Arabia in 2008 to that in 2011?
Make the answer very short. 1.02. What is the ratio of the Cost of communications, computer etc. (% of service imports) in Sudan in 2008 to that in 2011?
Offer a very short reply. 0.45. What is the ratio of the Cost of communications, computer etc. (% of service imports) of Guyana in 2008 to that in 2012?
Provide a succinct answer. 0.96. What is the ratio of the Cost of communications, computer etc. (% of service imports) of Saudi Arabia in 2008 to that in 2012?
Give a very brief answer. 1.14. What is the ratio of the Cost of communications, computer etc. (% of service imports) of Sudan in 2008 to that in 2012?
Give a very brief answer. 0.32. What is the ratio of the Cost of communications, computer etc. (% of service imports) in Guyana in 2009 to that in 2010?
Your answer should be very brief. 1.08. What is the ratio of the Cost of communications, computer etc. (% of service imports) in Saudi Arabia in 2009 to that in 2010?
Keep it short and to the point. 1.03. What is the ratio of the Cost of communications, computer etc. (% of service imports) in Sudan in 2009 to that in 2010?
Offer a terse response. 0.35. What is the ratio of the Cost of communications, computer etc. (% of service imports) of Guyana in 2009 to that in 2011?
Make the answer very short. 1.24. What is the ratio of the Cost of communications, computer etc. (% of service imports) in Saudi Arabia in 2009 to that in 2011?
Provide a succinct answer. 1.01. What is the ratio of the Cost of communications, computer etc. (% of service imports) of Sudan in 2009 to that in 2011?
Keep it short and to the point. 0.22. What is the ratio of the Cost of communications, computer etc. (% of service imports) in Guyana in 2009 to that in 2012?
Give a very brief answer. 1.1. What is the ratio of the Cost of communications, computer etc. (% of service imports) of Saudi Arabia in 2009 to that in 2012?
Offer a very short reply. 1.13. What is the ratio of the Cost of communications, computer etc. (% of service imports) of Sudan in 2009 to that in 2012?
Ensure brevity in your answer.  0.16. What is the ratio of the Cost of communications, computer etc. (% of service imports) in Guyana in 2010 to that in 2011?
Your answer should be very brief. 1.15. What is the ratio of the Cost of communications, computer etc. (% of service imports) of Saudi Arabia in 2010 to that in 2011?
Provide a succinct answer. 0.98. What is the ratio of the Cost of communications, computer etc. (% of service imports) of Sudan in 2010 to that in 2011?
Make the answer very short. 0.63. What is the ratio of the Cost of communications, computer etc. (% of service imports) of Saudi Arabia in 2010 to that in 2012?
Offer a very short reply. 1.09. What is the ratio of the Cost of communications, computer etc. (% of service imports) of Sudan in 2010 to that in 2012?
Make the answer very short. 0.44. What is the ratio of the Cost of communications, computer etc. (% of service imports) of Guyana in 2011 to that in 2012?
Offer a very short reply. 0.88. What is the ratio of the Cost of communications, computer etc. (% of service imports) in Saudi Arabia in 2011 to that in 2012?
Provide a succinct answer. 1.12. What is the ratio of the Cost of communications, computer etc. (% of service imports) in Sudan in 2011 to that in 2012?
Provide a short and direct response. 0.7. What is the difference between the highest and the second highest Cost of communications, computer etc. (% of service imports) in Guyana?
Make the answer very short. 3. What is the difference between the highest and the second highest Cost of communications, computer etc. (% of service imports) in Saudi Arabia?
Your answer should be very brief. 0.68. What is the difference between the highest and the second highest Cost of communications, computer etc. (% of service imports) of Sudan?
Your answer should be compact. 4.61. What is the difference between the highest and the lowest Cost of communications, computer etc. (% of service imports) in Guyana?
Offer a very short reply. 8.14. What is the difference between the highest and the lowest Cost of communications, computer etc. (% of service imports) in Saudi Arabia?
Provide a short and direct response. 7.41. What is the difference between the highest and the lowest Cost of communications, computer etc. (% of service imports) of Sudan?
Your response must be concise. 13.18. 